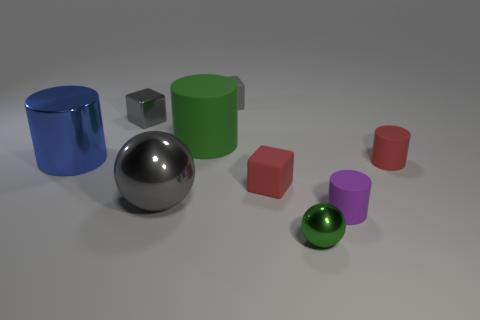How big is the gray object that is in front of the blue cylinder that is to the left of the small green metal object?
Keep it short and to the point. Large. There is a gray thing that is the same material as the green cylinder; what is its size?
Provide a succinct answer. Small. What is the shape of the tiny object that is on the left side of the purple rubber cylinder and in front of the big sphere?
Offer a very short reply. Sphere. Are there an equal number of small red matte cubes that are right of the tiny metallic sphere and cyan rubber spheres?
Your answer should be very brief. Yes. What number of things are either balls or rubber objects to the right of the purple matte cylinder?
Make the answer very short. 3. Is there a tiny red shiny object of the same shape as the green metal object?
Offer a very short reply. No. Are there the same number of green rubber things that are in front of the purple matte object and blue metallic cylinders to the right of the metallic block?
Ensure brevity in your answer.  Yes. Is there anything else that has the same size as the green ball?
Provide a short and direct response. Yes. What number of green things are small shiny things or small rubber things?
Ensure brevity in your answer.  1. What number of brown shiny blocks are the same size as the purple thing?
Make the answer very short. 0. 